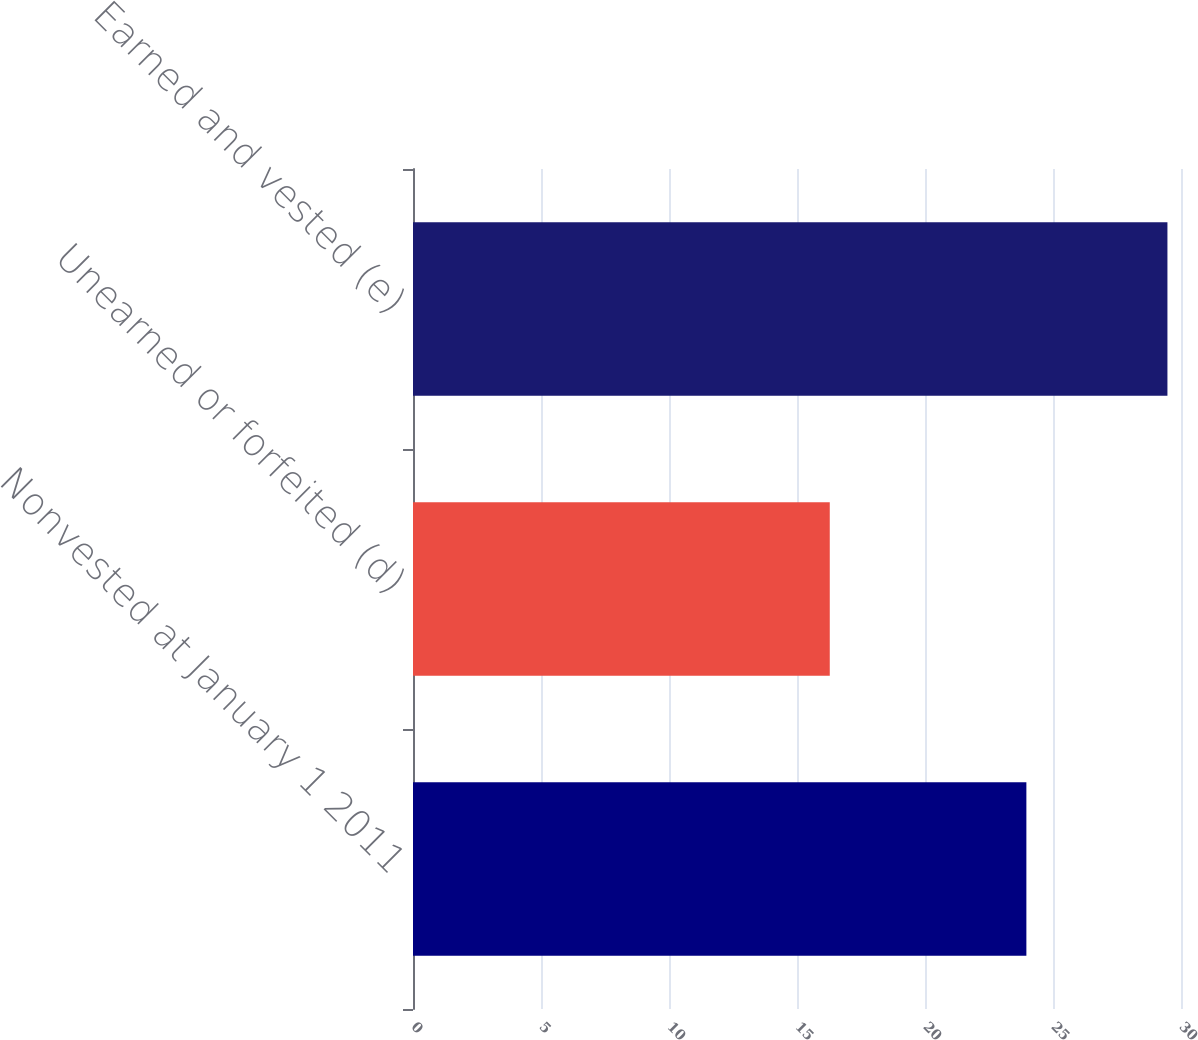<chart> <loc_0><loc_0><loc_500><loc_500><bar_chart><fcel>Nonvested at January 1 2011<fcel>Unearned or forfeited (d)<fcel>Earned and vested (e)<nl><fcel>23.96<fcel>16.28<fcel>29.47<nl></chart> 